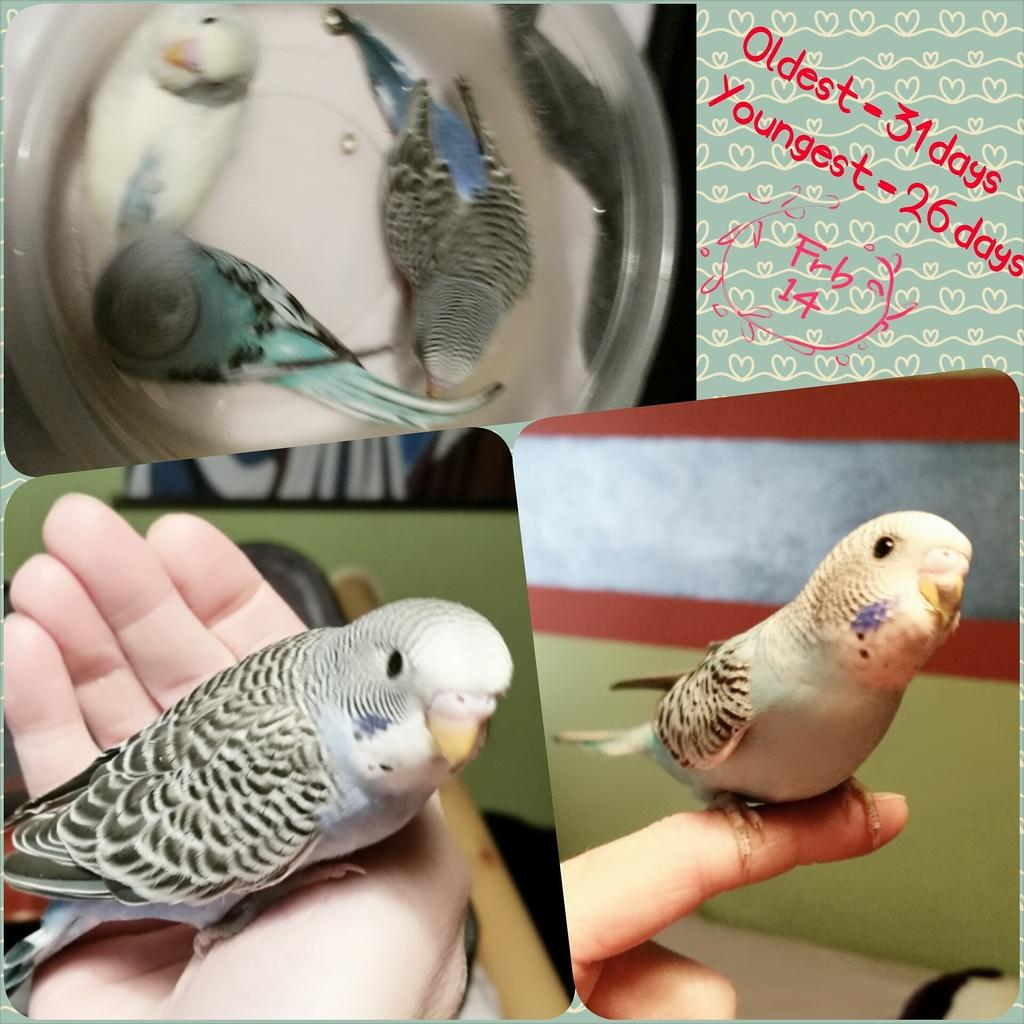What type of artwork is the image? The image is a collage. How many birds are present in the collage? There are five birds in the image. How many women are present in the image? There are no women present in the image; it is a collage of birds. What type of shoe can be seen in the image? There is no shoe present in the image; it is a collage of birds. 